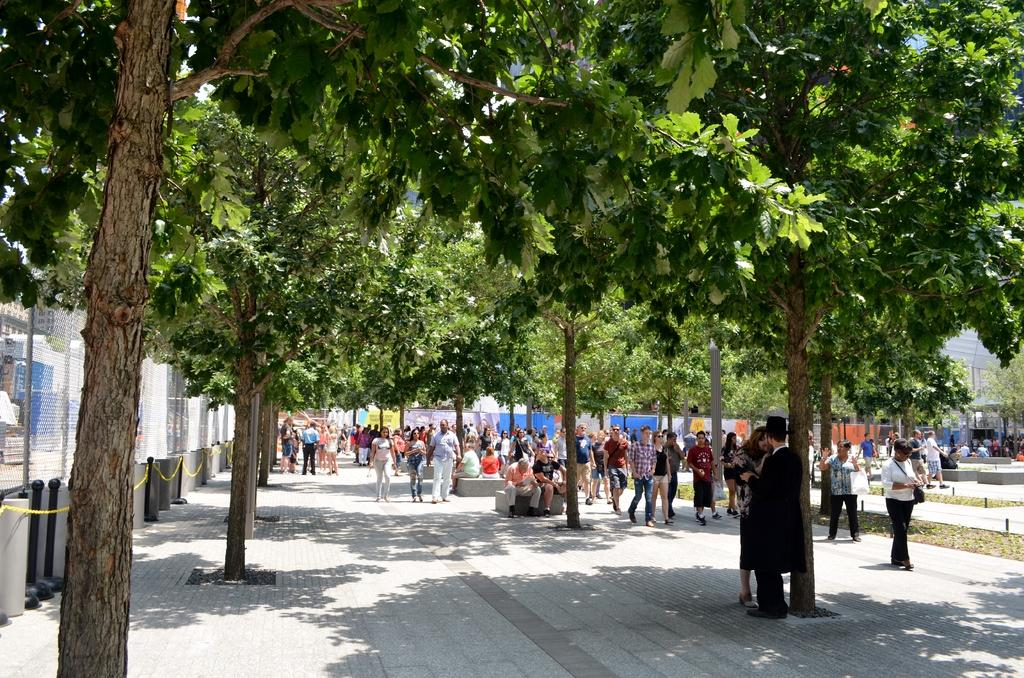What can be seen in the image that people might walk on? There is a path in the image that people might walk on. Are there any people visible on the path? Yes, there are people on the path in the image. What type of natural scenery can be seen in the image? There are trees visible in the image. What type of tax is being discussed by the people on the path in the image? There is no indication in the image that the people on the path are discussing any type of tax. 